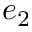<formula> <loc_0><loc_0><loc_500><loc_500>e _ { 2 }</formula> 